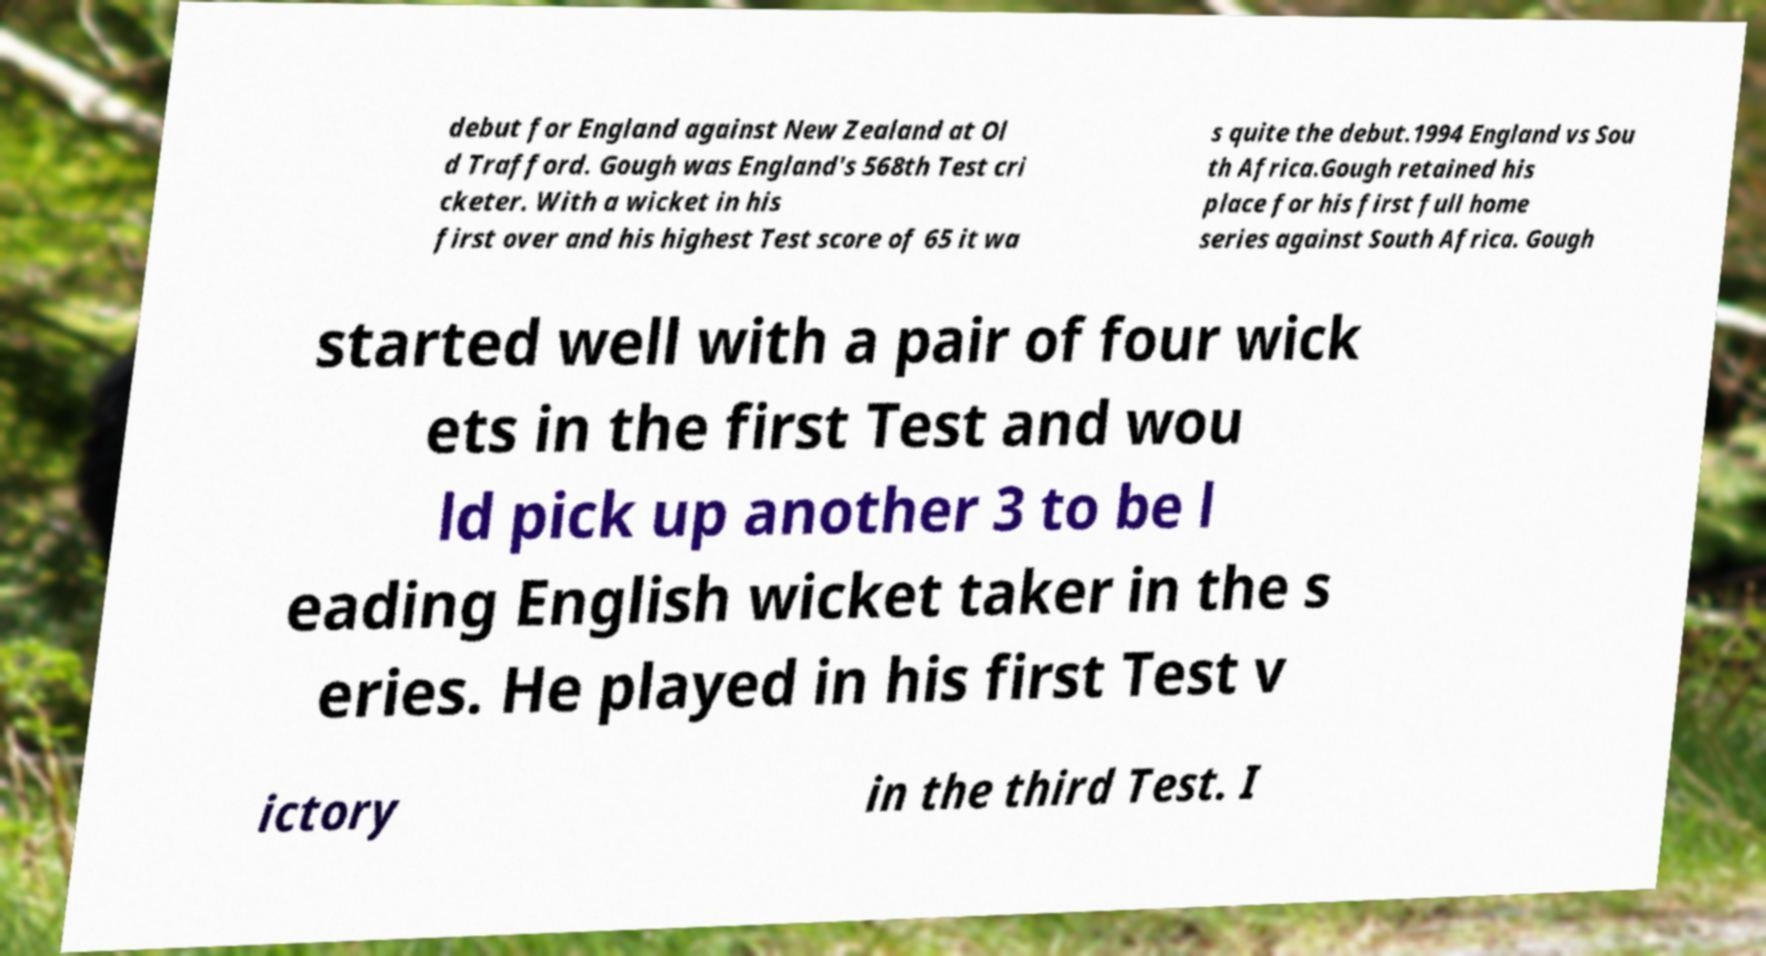Please read and relay the text visible in this image. What does it say? debut for England against New Zealand at Ol d Trafford. Gough was England's 568th Test cri cketer. With a wicket in his first over and his highest Test score of 65 it wa s quite the debut.1994 England vs Sou th Africa.Gough retained his place for his first full home series against South Africa. Gough started well with a pair of four wick ets in the first Test and wou ld pick up another 3 to be l eading English wicket taker in the s eries. He played in his first Test v ictory in the third Test. I 